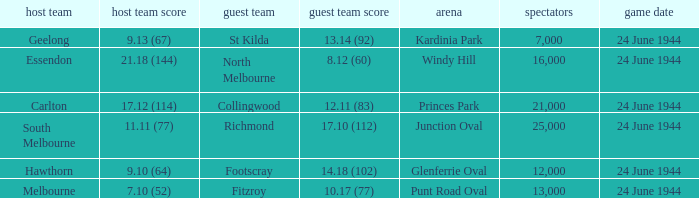When the Crowd was larger than 25,000. what was the Home Team score? None. 